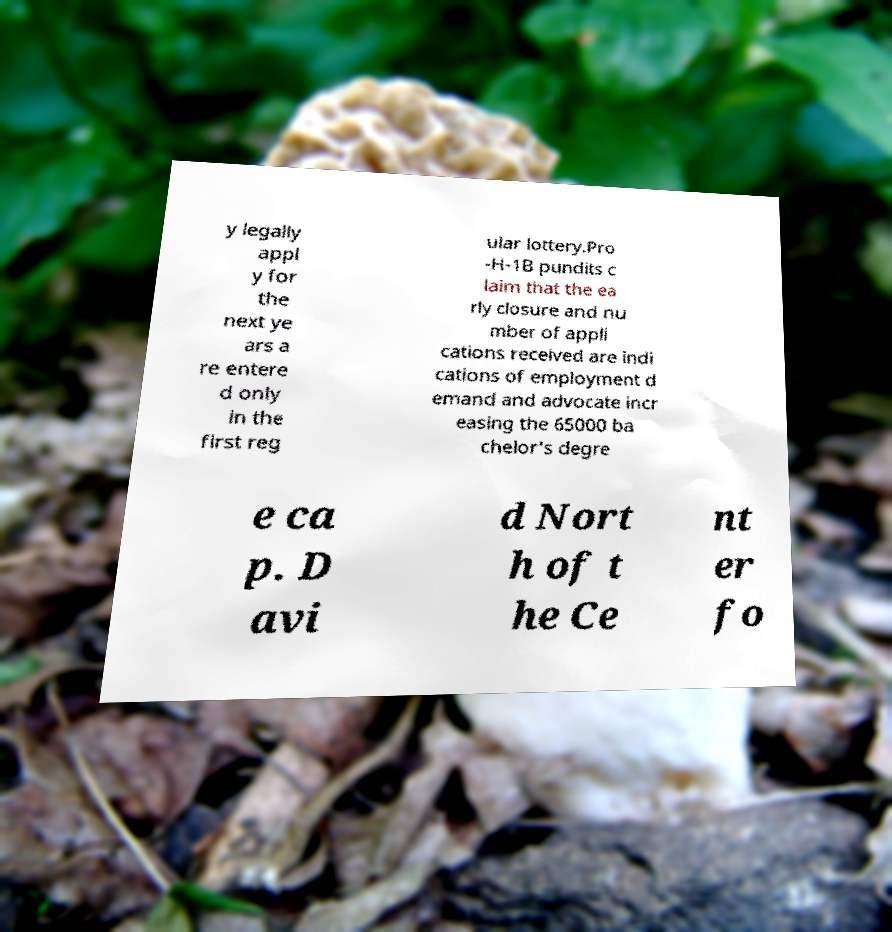For documentation purposes, I need the text within this image transcribed. Could you provide that? y legally appl y for the next ye ars a re entere d only in the first reg ular lottery.Pro -H-1B pundits c laim that the ea rly closure and nu mber of appli cations received are indi cations of employment d emand and advocate incr easing the 65000 ba chelor's degre e ca p. D avi d Nort h of t he Ce nt er fo 